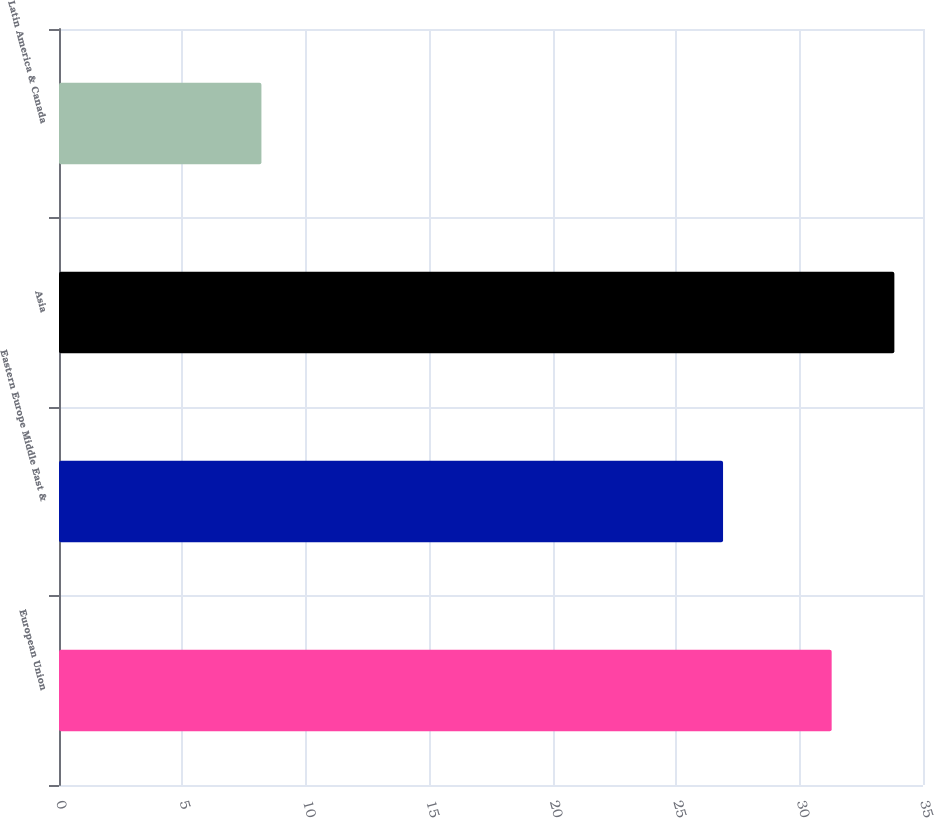<chart> <loc_0><loc_0><loc_500><loc_500><bar_chart><fcel>European Union<fcel>Eastern Europe Middle East &<fcel>Asia<fcel>Latin America & Canada<nl><fcel>31.3<fcel>26.9<fcel>33.84<fcel>8.2<nl></chart> 